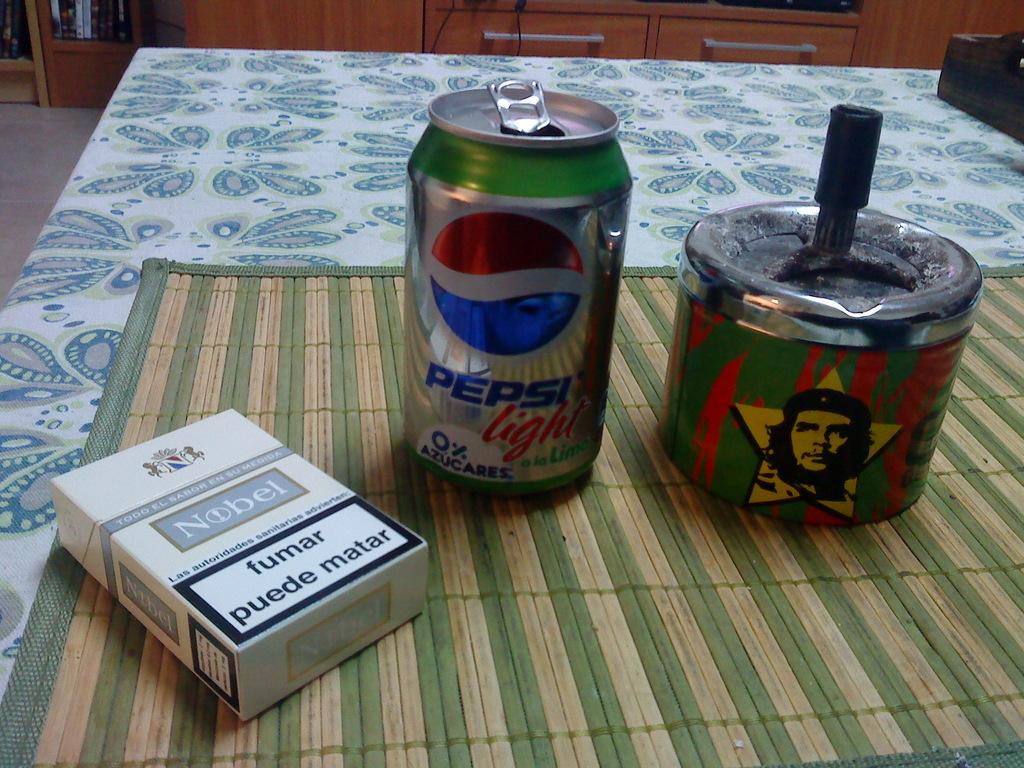Provide a one-sentence caption for the provided image. a Pepsi can that is on a green surface. 